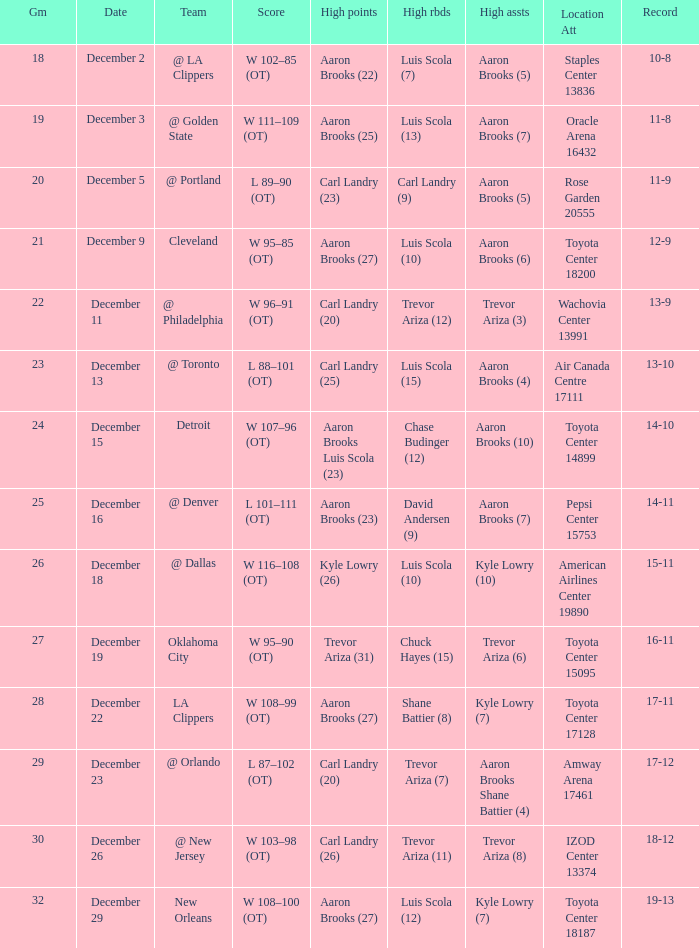What's the end score of the game where Shane Battier (8) did the high rebounds? W 108–99 (OT). 